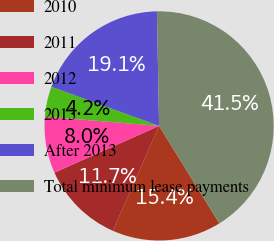<chart> <loc_0><loc_0><loc_500><loc_500><pie_chart><fcel>2010<fcel>2011<fcel>2012<fcel>2013<fcel>After 2013<fcel>Total minimum lease payments<nl><fcel>15.43%<fcel>11.7%<fcel>7.98%<fcel>4.25%<fcel>19.15%<fcel>41.49%<nl></chart> 